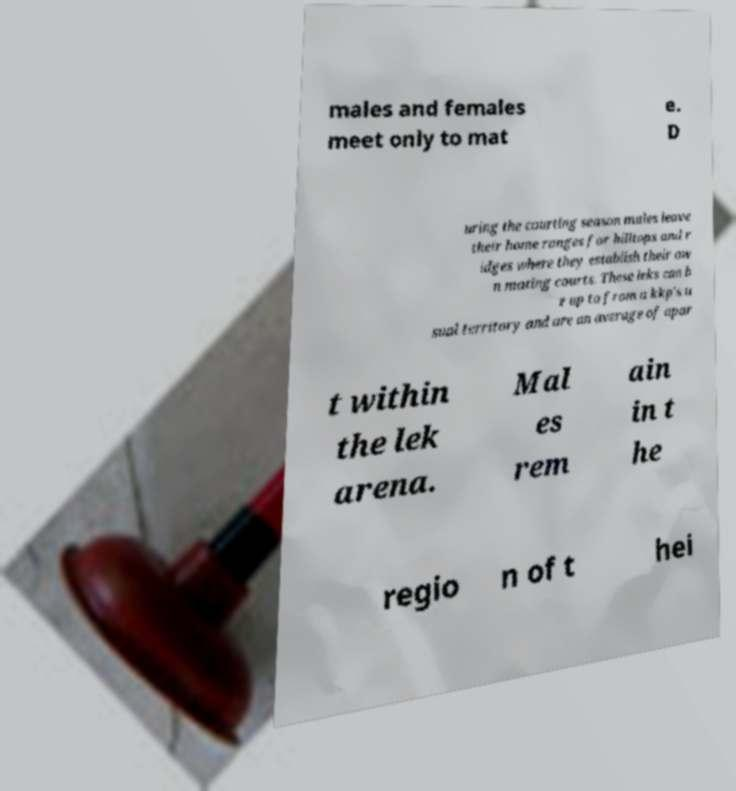Can you read and provide the text displayed in the image?This photo seems to have some interesting text. Can you extract and type it out for me? males and females meet only to mat e. D uring the courting season males leave their home ranges for hilltops and r idges where they establish their ow n mating courts. These leks can b e up to from a kkp's u sual territory and are an average of apar t within the lek arena. Mal es rem ain in t he regio n of t hei 